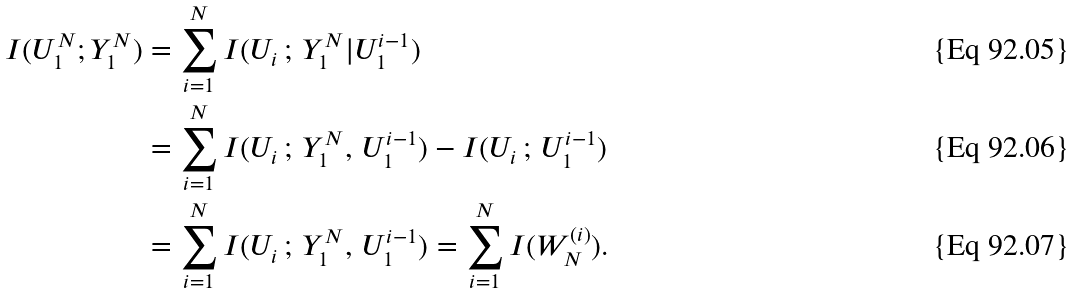<formula> <loc_0><loc_0><loc_500><loc_500>I ( U _ { 1 } ^ { N } ; Y _ { 1 } ^ { N } ) & = \sum _ { i = 1 } ^ { N } I ( U _ { i } \, ; \, Y _ { 1 } ^ { N } | U _ { 1 } ^ { i - 1 } ) \\ & = \sum _ { i = 1 } ^ { N } I ( U _ { i } \, ; \, Y _ { 1 } ^ { N } , \, U _ { 1 } ^ { i - 1 } ) - I ( U _ { i } \, ; \, U _ { 1 } ^ { i - 1 } ) \\ & = \sum _ { i = 1 } ^ { N } I ( U _ { i } \, ; \, Y _ { 1 } ^ { N } , \, U _ { 1 } ^ { i - 1 } ) = \sum _ { i = 1 } ^ { N } I ( W _ { N } ^ { ( i ) } ) \text {.}</formula> 